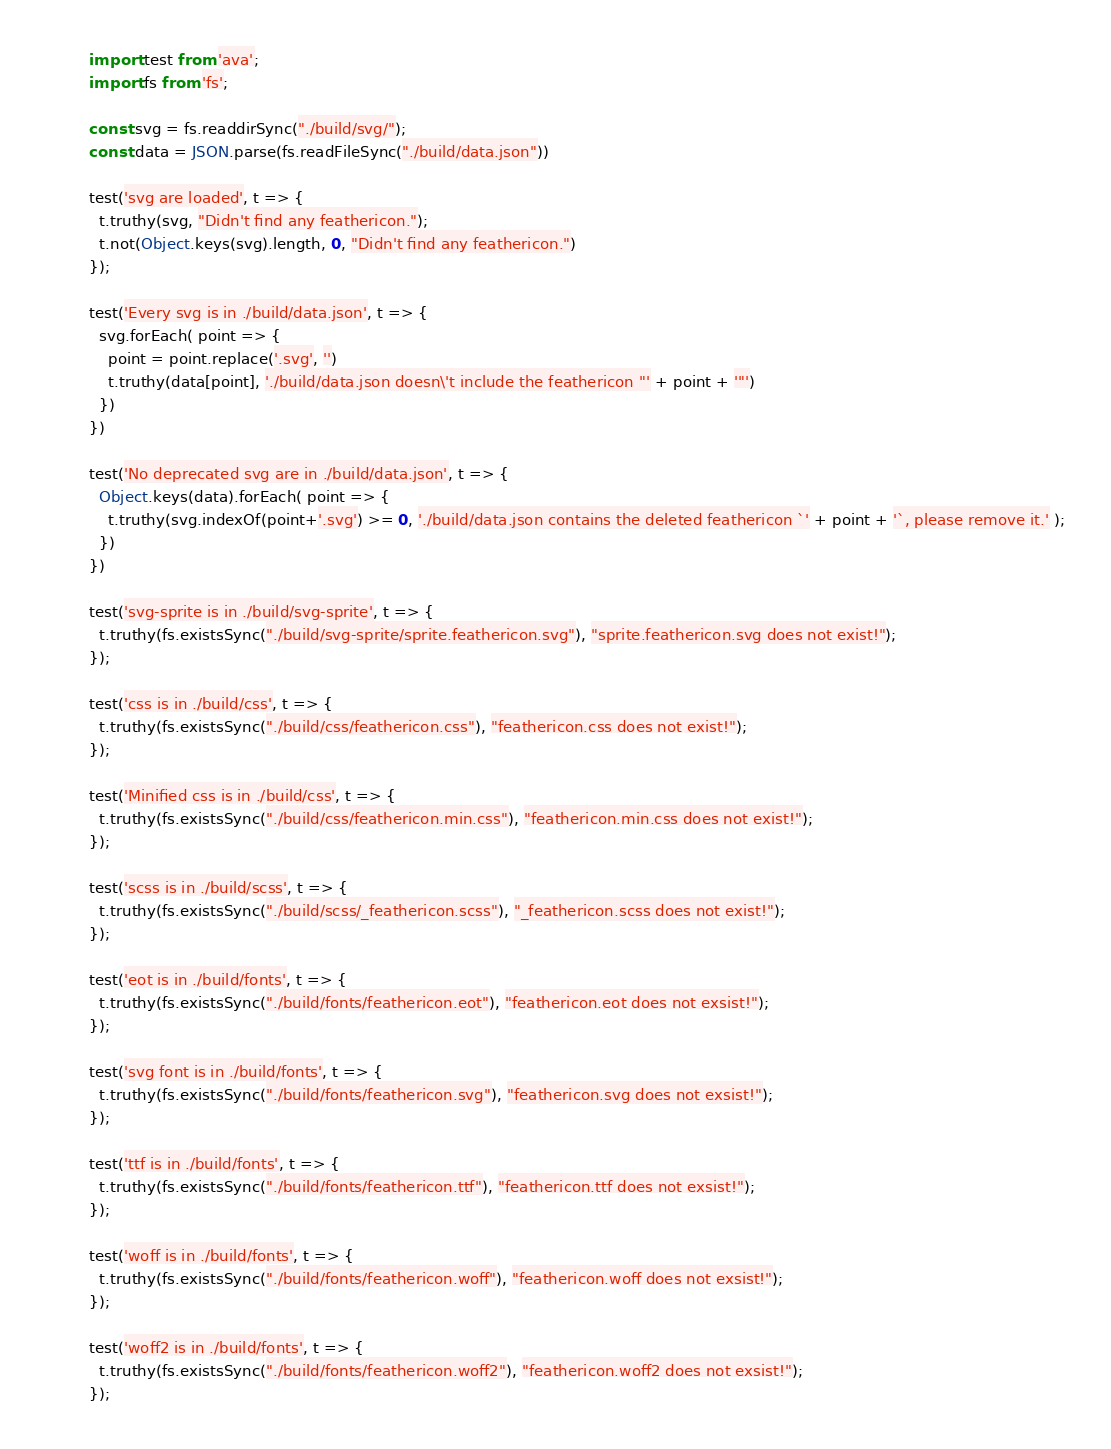Convert code to text. <code><loc_0><loc_0><loc_500><loc_500><_JavaScript_>import test from 'ava';
import fs from 'fs';

const svg = fs.readdirSync("./build/svg/");
const data = JSON.parse(fs.readFileSync("./build/data.json"))

test('svg are loaded', t => {
  t.truthy(svg, "Didn't find any feathericon.");
  t.not(Object.keys(svg).length, 0, "Didn't find any feathericon.")
});

test('Every svg is in ./build/data.json', t => {
  svg.forEach( point => {
    point = point.replace('.svg', '')
    t.truthy(data[point], './build/data.json doesn\'t include the feathericon "' + point + '"')
  })
})

test('No deprecated svg are in ./build/data.json', t => {
  Object.keys(data).forEach( point => {
    t.truthy(svg.indexOf(point+'.svg') >= 0, './build/data.json contains the deleted feathericon `' + point + '`, please remove it.' );
  })
})

test('svg-sprite is in ./build/svg-sprite', t => {
  t.truthy(fs.existsSync("./build/svg-sprite/sprite.feathericon.svg"), "sprite.feathericon.svg does not exist!");
});

test('css is in ./build/css', t => {
  t.truthy(fs.existsSync("./build/css/feathericon.css"), "feathericon.css does not exist!");
});

test('Minified css is in ./build/css', t => {
  t.truthy(fs.existsSync("./build/css/feathericon.min.css"), "feathericon.min.css does not exist!");
});

test('scss is in ./build/scss', t => {
  t.truthy(fs.existsSync("./build/scss/_feathericon.scss"), "_feathericon.scss does not exist!");
});

test('eot is in ./build/fonts', t => {
  t.truthy(fs.existsSync("./build/fonts/feathericon.eot"), "feathericon.eot does not exsist!");
});

test('svg font is in ./build/fonts', t => {
  t.truthy(fs.existsSync("./build/fonts/feathericon.svg"), "feathericon.svg does not exsist!");
});

test('ttf is in ./build/fonts', t => {
  t.truthy(fs.existsSync("./build/fonts/feathericon.ttf"), "feathericon.ttf does not exsist!");
});

test('woff is in ./build/fonts', t => {
  t.truthy(fs.existsSync("./build/fonts/feathericon.woff"), "feathericon.woff does not exsist!");
});

test('woff2 is in ./build/fonts', t => {
  t.truthy(fs.existsSync("./build/fonts/feathericon.woff2"), "feathericon.woff2 does not exsist!");
});
</code> 